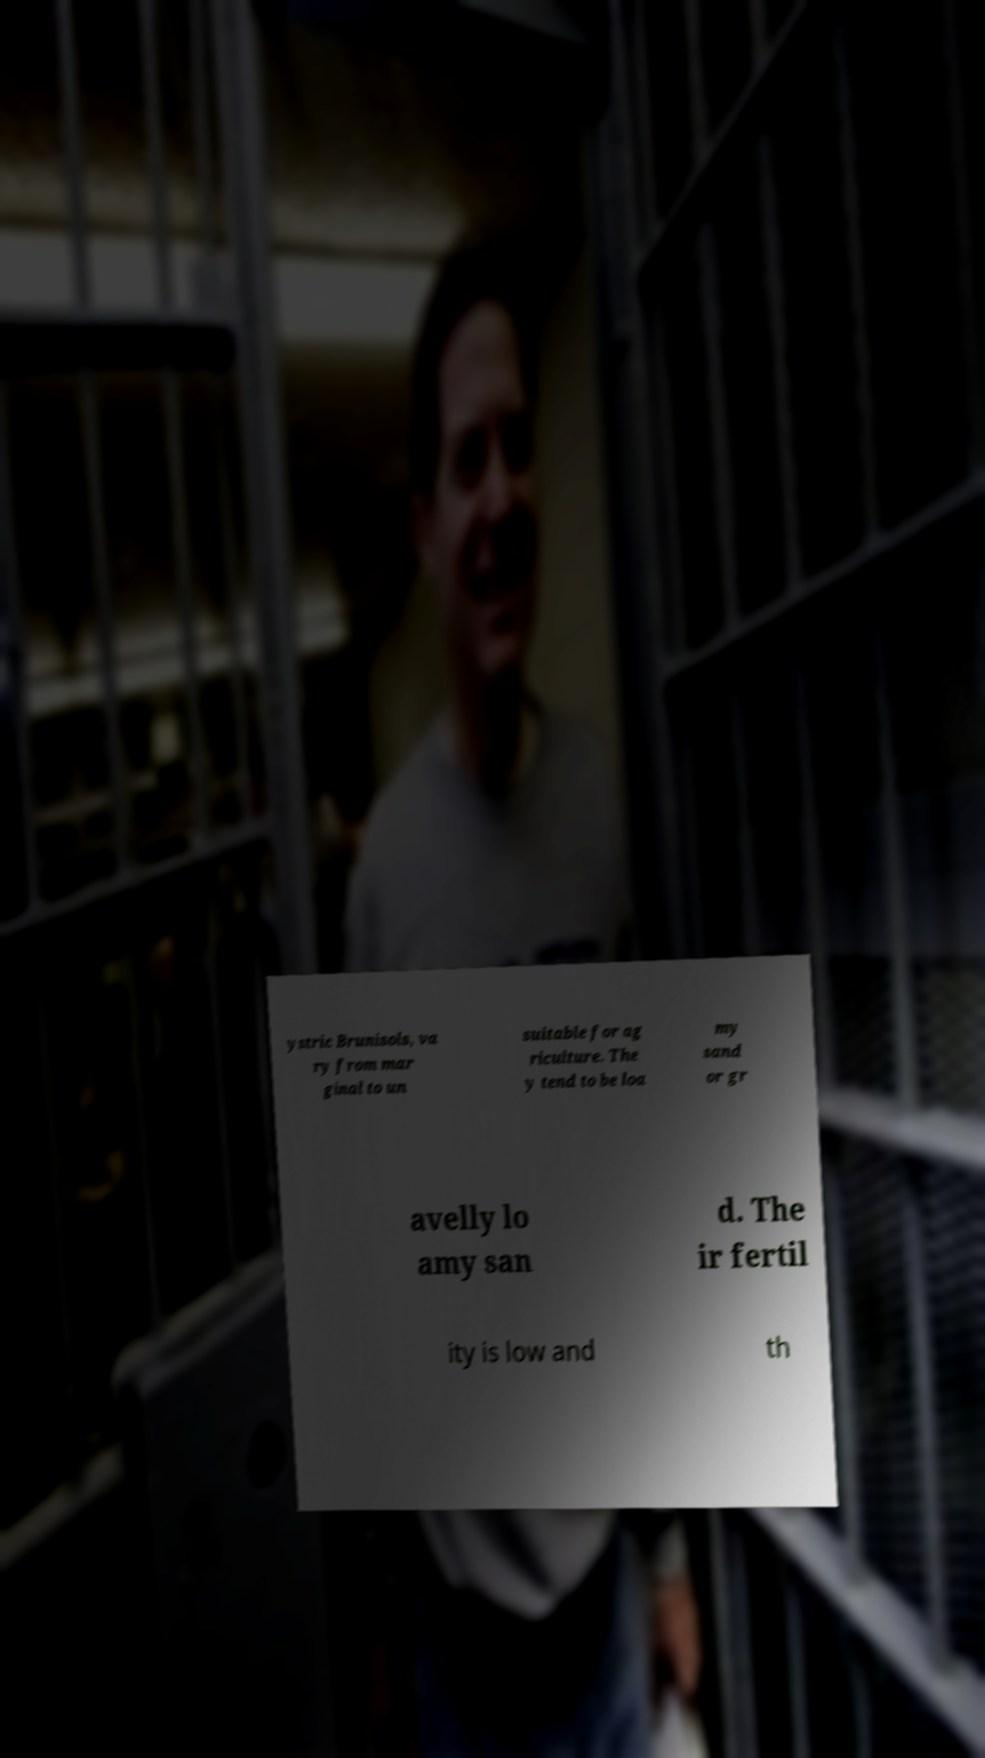What messages or text are displayed in this image? I need them in a readable, typed format. ystric Brunisols, va ry from mar ginal to un suitable for ag riculture. The y tend to be loa my sand or gr avelly lo amy san d. The ir fertil ity is low and th 